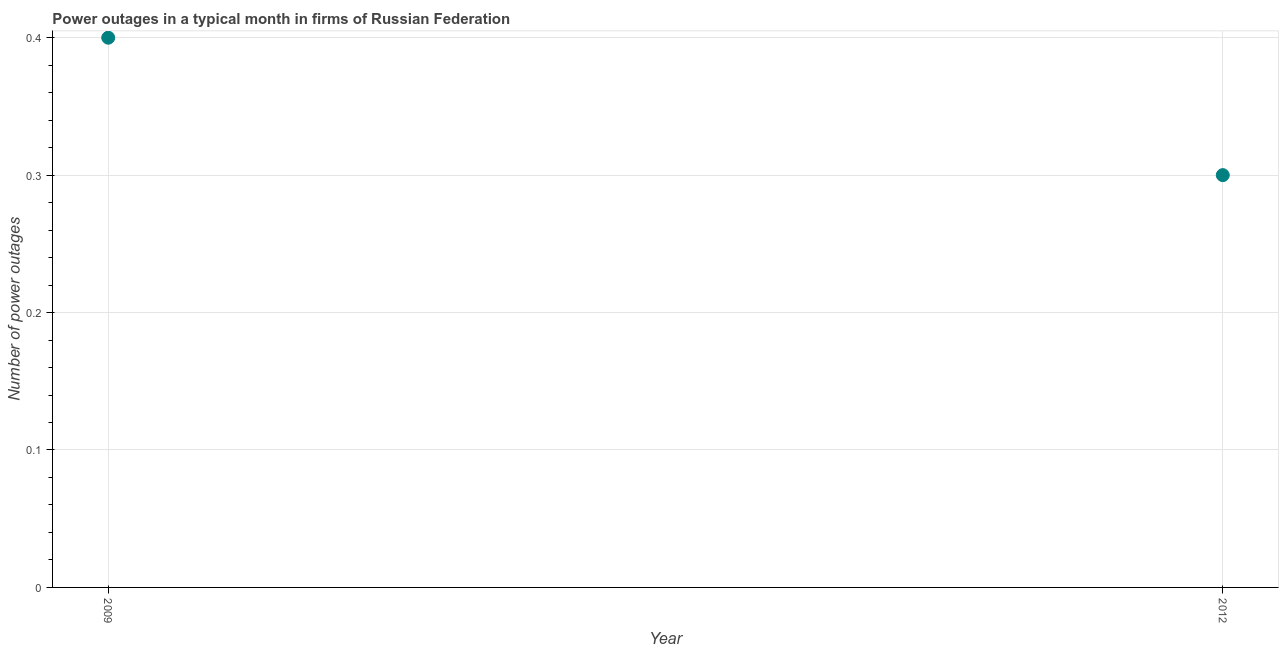What is the number of power outages in 2012?
Your answer should be compact. 0.3. In which year was the number of power outages minimum?
Keep it short and to the point. 2012. What is the sum of the number of power outages?
Provide a short and direct response. 0.7. What is the difference between the number of power outages in 2009 and 2012?
Provide a succinct answer. 0.1. What is the average number of power outages per year?
Make the answer very short. 0.35. What is the median number of power outages?
Offer a terse response. 0.35. What is the ratio of the number of power outages in 2009 to that in 2012?
Keep it short and to the point. 1.33. Is the number of power outages in 2009 less than that in 2012?
Keep it short and to the point. No. Does the number of power outages monotonically increase over the years?
Keep it short and to the point. No. How many years are there in the graph?
Give a very brief answer. 2. What is the difference between two consecutive major ticks on the Y-axis?
Ensure brevity in your answer.  0.1. Are the values on the major ticks of Y-axis written in scientific E-notation?
Offer a very short reply. No. Does the graph contain any zero values?
Your response must be concise. No. Does the graph contain grids?
Ensure brevity in your answer.  Yes. What is the title of the graph?
Your answer should be very brief. Power outages in a typical month in firms of Russian Federation. What is the label or title of the Y-axis?
Ensure brevity in your answer.  Number of power outages. What is the Number of power outages in 2009?
Keep it short and to the point. 0.4. What is the Number of power outages in 2012?
Your answer should be very brief. 0.3. What is the ratio of the Number of power outages in 2009 to that in 2012?
Keep it short and to the point. 1.33. 